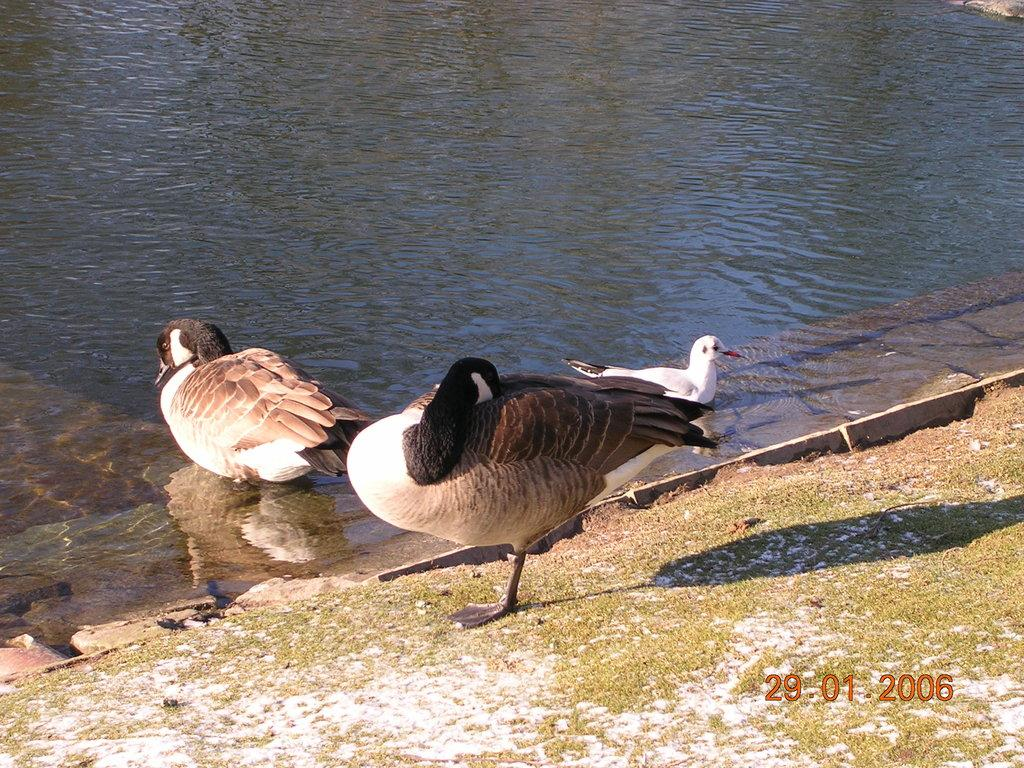What type of animals can be seen in the image? There are birds in the image. Where are some of the birds located in the image? Two of the birds are in the water. Is there any additional information about the image itself? Yes, there is a watermark on the image. What is the name of the governor of the nation depicted in the image? There is no nation depicted in the image, and therefore no governor to identify. 